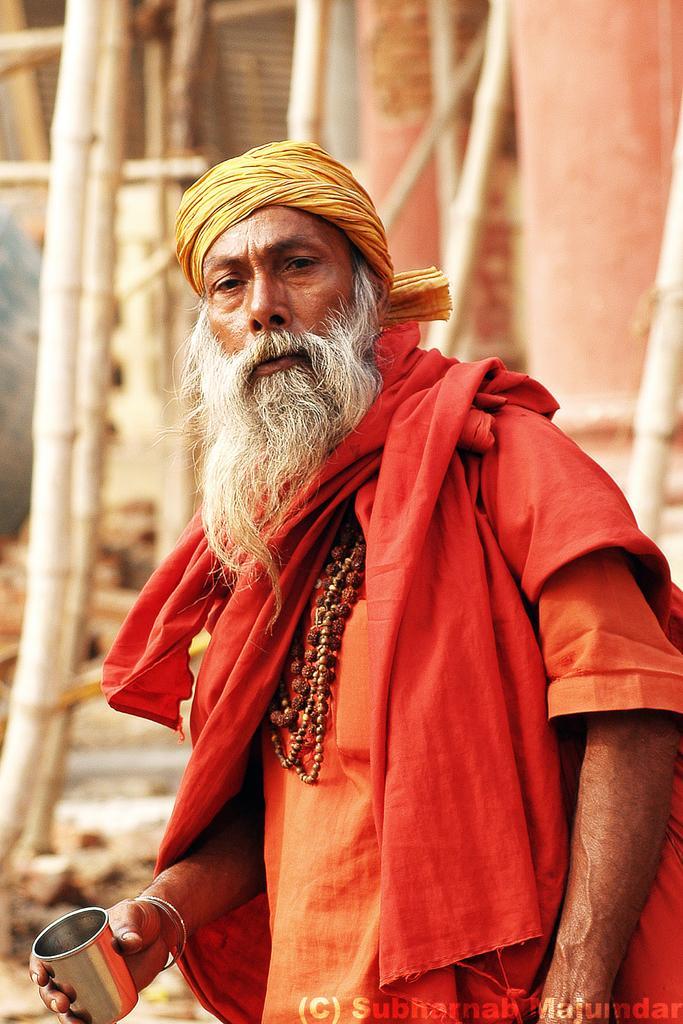Can you describe this image briefly? In this image I can see the person and the person is wearing orange color dress and holding the glass. In the background I can see few wooden sticks. 